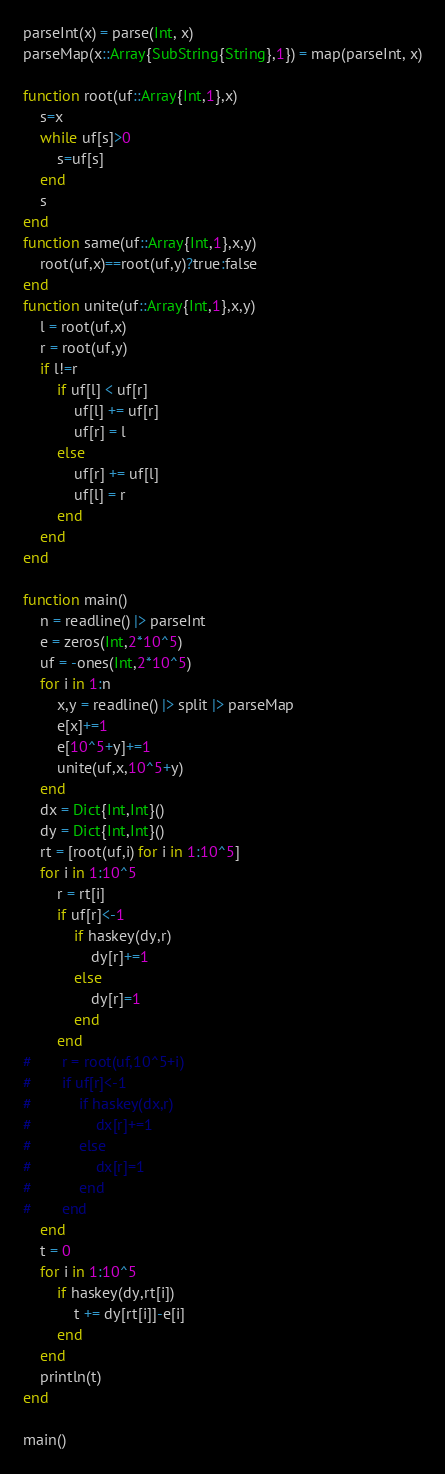<code> <loc_0><loc_0><loc_500><loc_500><_Julia_>parseInt(x) = parse(Int, x)
parseMap(x::Array{SubString{String},1}) = map(parseInt, x)

function root(uf::Array{Int,1},x)
	s=x
	while uf[s]>0
		s=uf[s]
	end
	s
end
function same(uf::Array{Int,1},x,y)
	root(uf,x)==root(uf,y)?true:false
end
function unite(uf::Array{Int,1},x,y)
	l = root(uf,x)
	r = root(uf,y)
	if l!=r
		if uf[l] < uf[r]
			uf[l] += uf[r]
			uf[r] = l
		else
			uf[r] += uf[l]
			uf[l] = r
		end
	end
end

function main()
	n = readline() |> parseInt
	e = zeros(Int,2*10^5)
	uf = -ones(Int,2*10^5)
	for i in 1:n
		x,y = readline() |> split |> parseMap
		e[x]+=1
		e[10^5+y]+=1
		unite(uf,x,10^5+y)
	end
	dx = Dict{Int,Int}()
	dy = Dict{Int,Int}()
	rt = [root(uf,i) for i in 1:10^5]
	for i in 1:10^5
		r = rt[i]
		if uf[r]<-1
			if haskey(dy,r)
				dy[r]+=1
			else
				dy[r]=1
			end
		end
#		r = root(uf,10^5+i)
#		if uf[r]<-1
#			if haskey(dx,r)
#				dx[r]+=1
#			else
#				dx[r]=1
#			end
#		end
	end
	t = 0
	for i in 1:10^5
		if haskey(dy,rt[i])
			t += dy[rt[i]]-e[i]
		end
	end
	println(t)
end

main()</code> 